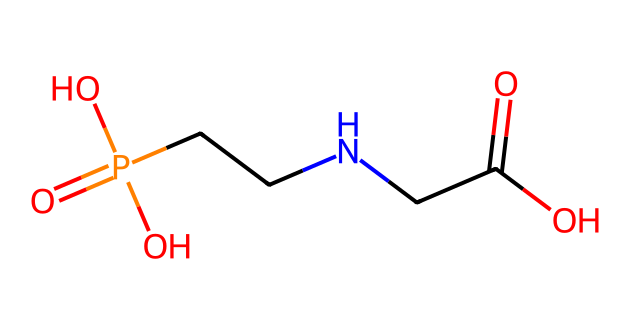How many carbon atoms are in the chemical structure? By analyzing the provided SMILES representation, we see the "C" character indicates carbon atoms. Counting the "C" characters in the structure shows there are two carbons.
Answer: two What is the total number of nitrogen atoms in this chemical? The SMILES contains one "N" character, indicating the presence of a single nitrogen atom.
Answer: one What functional group is represented by the "C(=O)O" section? The "(=O)O" signifies a carboxylic acid functional group, characterized by a carbon atom double-bonded to an oxygen atom and single-bonded to a hydroxyl group (OH).
Answer: carboxylic acid What is the role of the phosphorus atom in this compound? The "P" in the structure indicates the presence of a phosphate group, which is commonly involved in energy transfer and the metabolic processes of living organisms.
Answer: energy transfer How does the presence of the nitrogen atom affect the herbicidal activity of glyphosate? The nitrogen in glyphosate contributes to its ability to inhibit specific enzymes involved in aromatic amino acid synthesis, which is critical in many plants and some microorganisms. This inhibition leads to its effectiveness as a herbicide.
Answer: inhibition of enzymes What type of bond is indicated between the carbon and oxygen in the carboxylic acid group? The connection between carbon and oxygen in the carboxylic acid group is a double bond for the carbonyl (C=O) part, while the hydroxyl (OH) part is a single bond.
Answer: double bond and single bond 